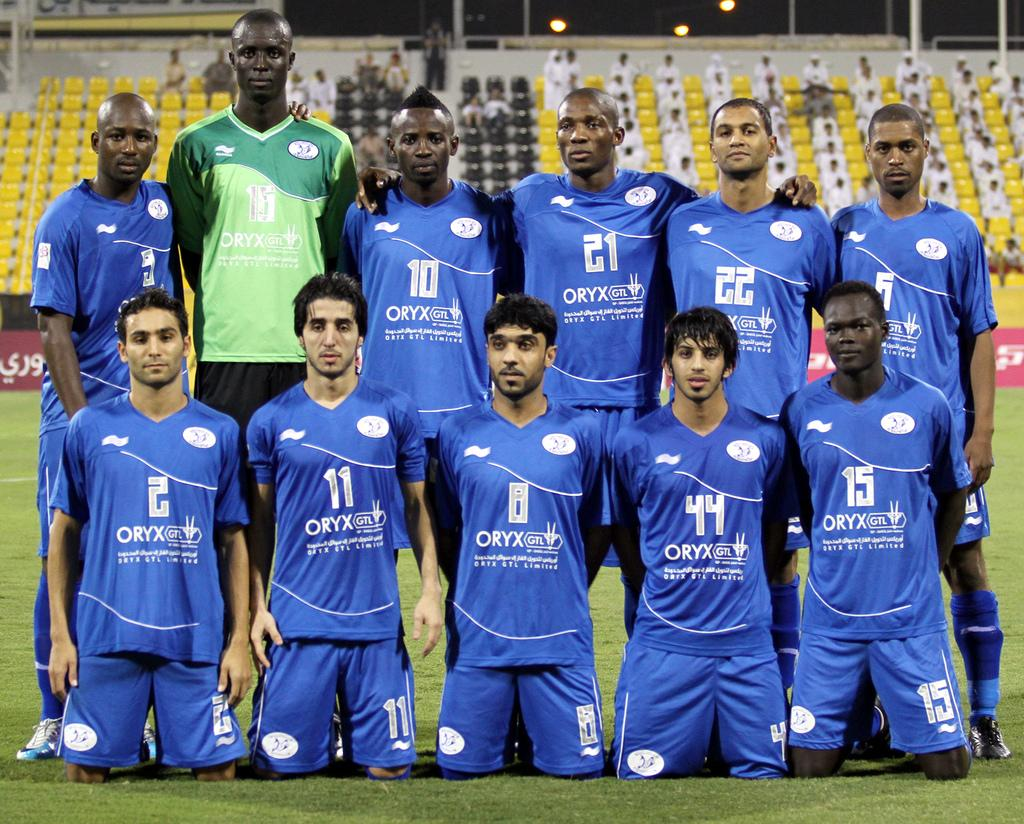Provide a one-sentence caption for the provided image. A sports team is posing together for a group photo with ORYX on their shirts. 